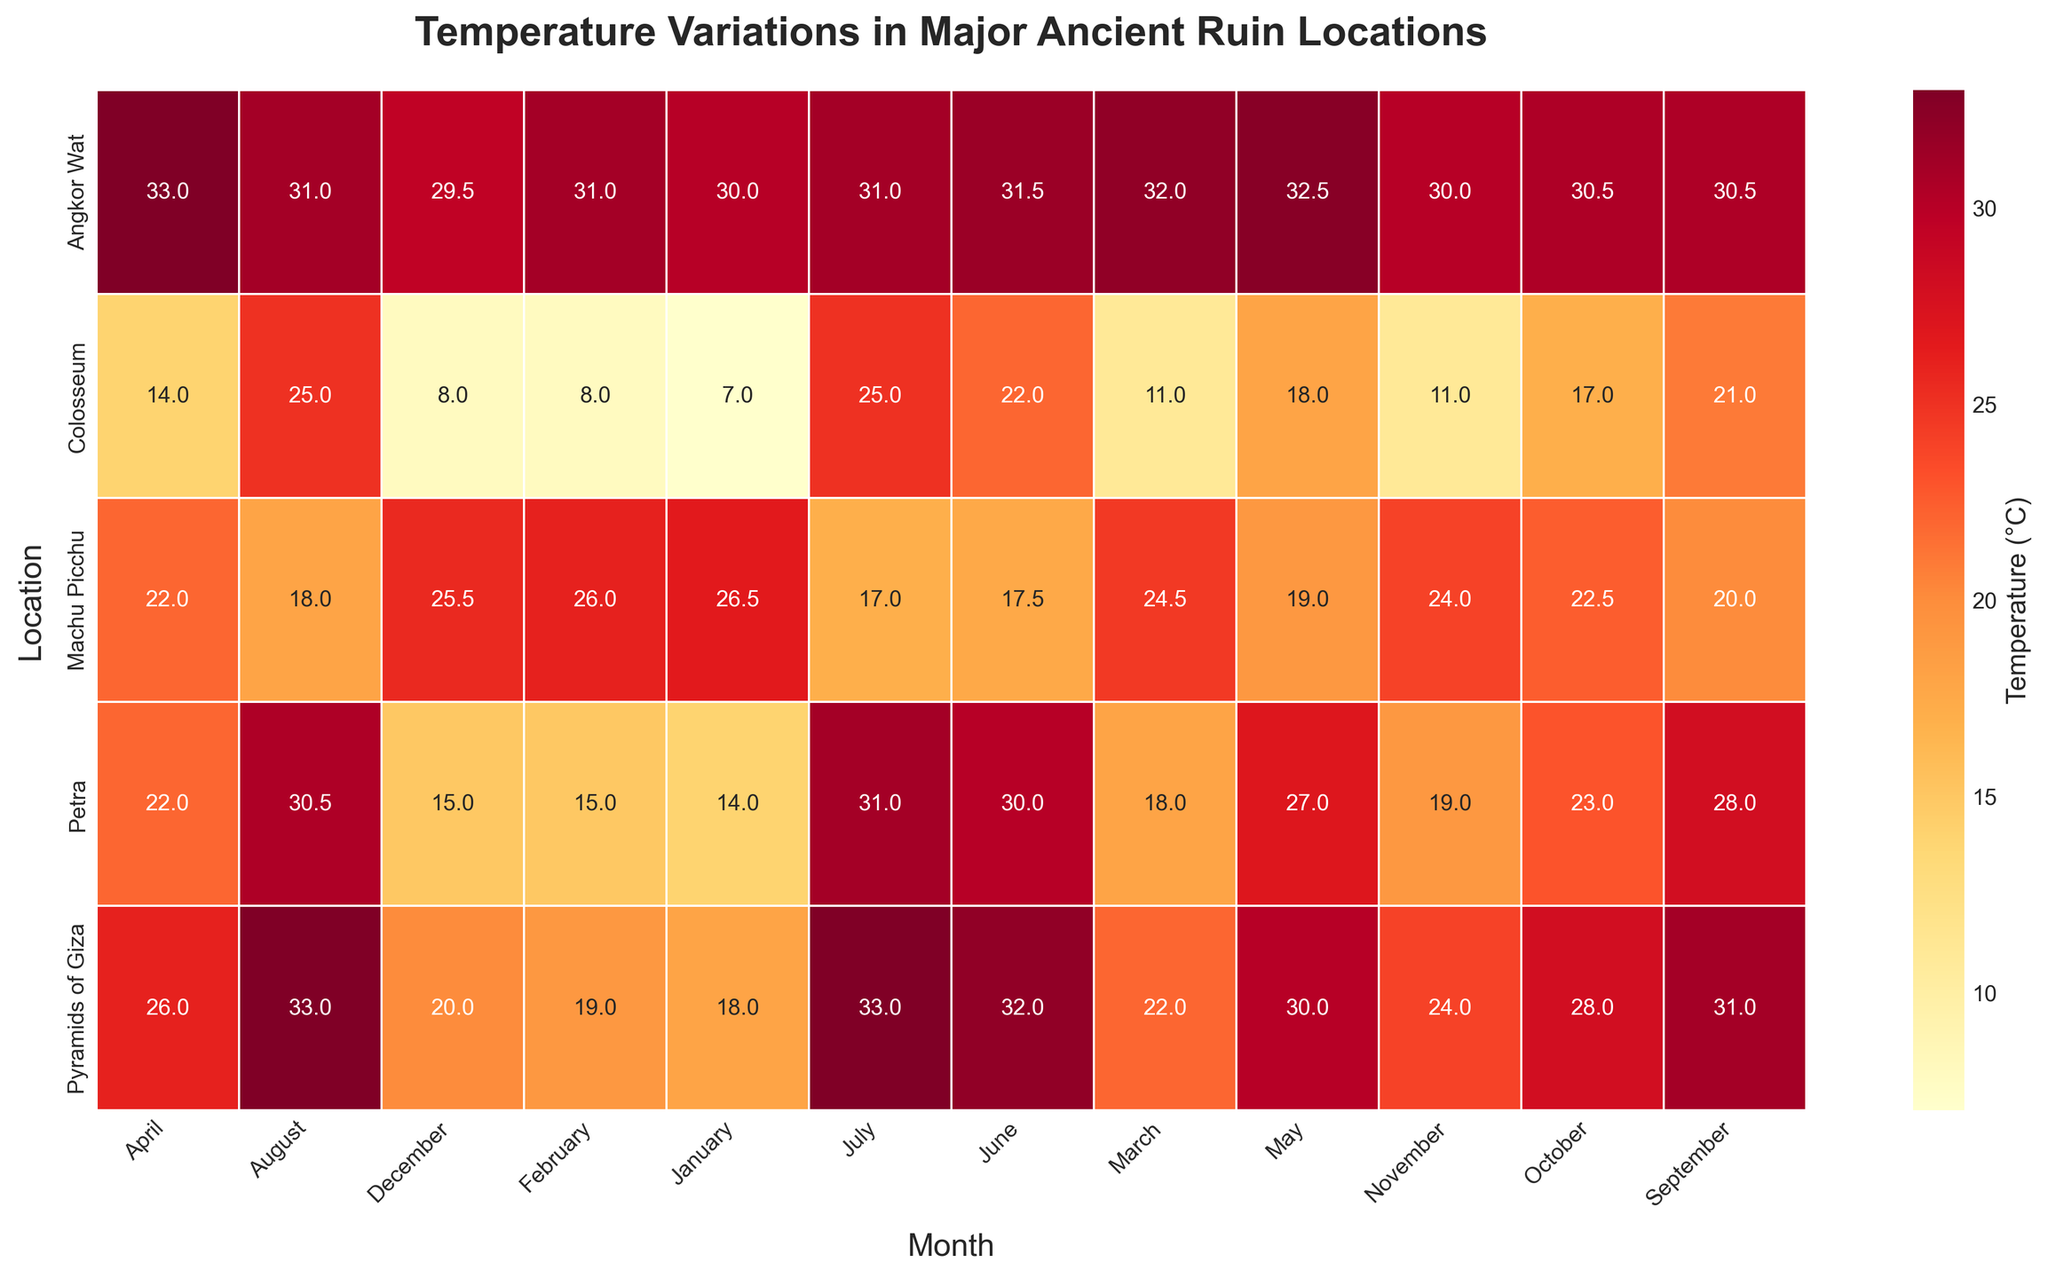What is the title of the heatmap? The title is usually displayed at the top of the heatmap. In this case, it is formatted in bold for emphasis. The title indicates the subject of the heatmap, which in this case is temperature variations.
Answer: Temperature Variations in Major Ancient Ruin Locations Which location has the highest average temperature in July? By scanning the heatmap for the month of July, we look at the values for each location. The highest value in July is for Pyramids of Giza at 33.0°C.
Answer: Pyramids of Giza Which month generally shows the lowest average temperature across all the locations? By scanning across each location's row for low values, January for Colosseum shows 7.0°C as the lowest. So January has the generally lowest temperatures across locations.
Answer: January What is the average temperature in Petra in March and how does it compare to April? Look at the values for Petra in both March (18.0°C) and April (22.0°C). To compare, April has a higher temperature.
Answer: Petra's average temperature in March is 18.0°C and in April it is 22.0°C; April is warmer Which ancient ruin location exhibits the least temperature variation throughout the year? Calculate the range (difference between highest and lowest values) for each location. Angkor Wat's temperatures range from 29.5°C to 33.0°C, which is the smallest variation of 3.5°C.
Answer: Angkor Wat Between Machu Picchu and the Colosseum, which site has a cooler average temperature in September? Compare the temperatures in September for both sites: Machu Picchu (20.0°C) and Colosseum (21.0°C). Colosseum is slightly warmer.
Answer: Machu Picchu Among the listed locations, which one has the hottest average temperature in any month and what is that temperature? Scan each entry to find the highest temperature value. The highest temperature is in Angkor Wat in April (33.0°C), Pyramids of Giza in July (33.0°C), and August (33.0°C).
Answer: Angkor Wat, April; Pyramids of Giza, July and August, 33.0°C How does the average temperature in November at Machu Picchu compare to Petra? Refer to November values: Machu Picchu (24.0°C) and Petra (19.0°C). Machu Picchu is warmer by 5.0°C.
Answer: Machu Picchu is 5.0°C warmer What is the temperature difference between the hottest and coldest months at the Colosseum? Identify the highest and lowest values for the Colosseum: July and August (25.0°C) and January (7.0°C). The temperature difference is 25.0°C - 7.0°C.
Answer: 18.0°C Which two locations have their hottest months in September and what are their respective temperatures? Locate the temperature for September; no location has the peak highest temperature in this month. Most values decrease or hold steady.
Answer: None 